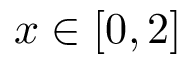Convert formula to latex. <formula><loc_0><loc_0><loc_500><loc_500>x \in [ 0 , 2 ]</formula> 